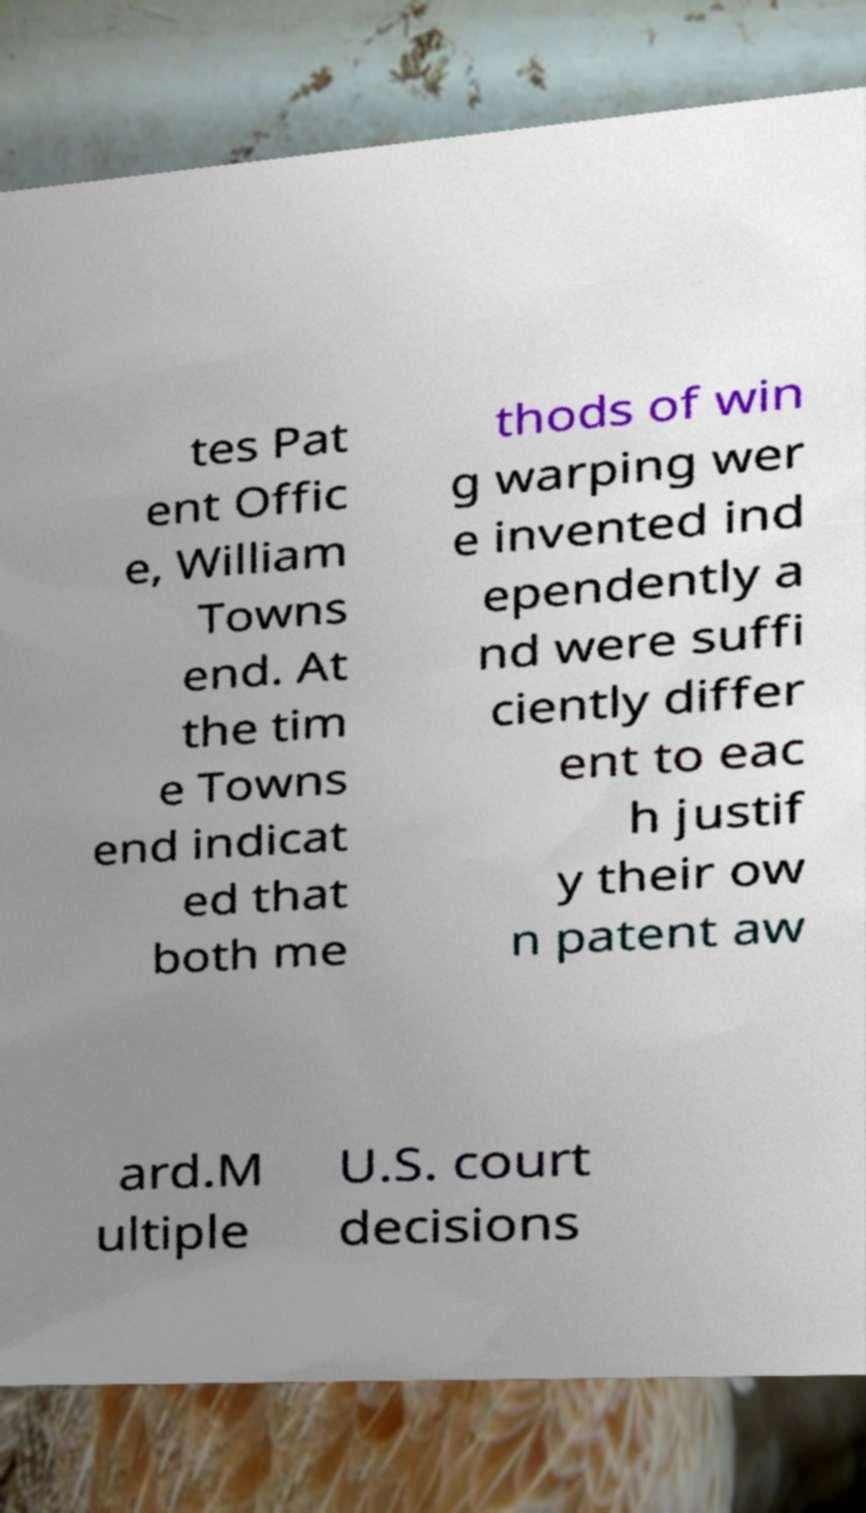Please read and relay the text visible in this image. What does it say? tes Pat ent Offic e, William Towns end. At the tim e Towns end indicat ed that both me thods of win g warping wer e invented ind ependently a nd were suffi ciently differ ent to eac h justif y their ow n patent aw ard.M ultiple U.S. court decisions 